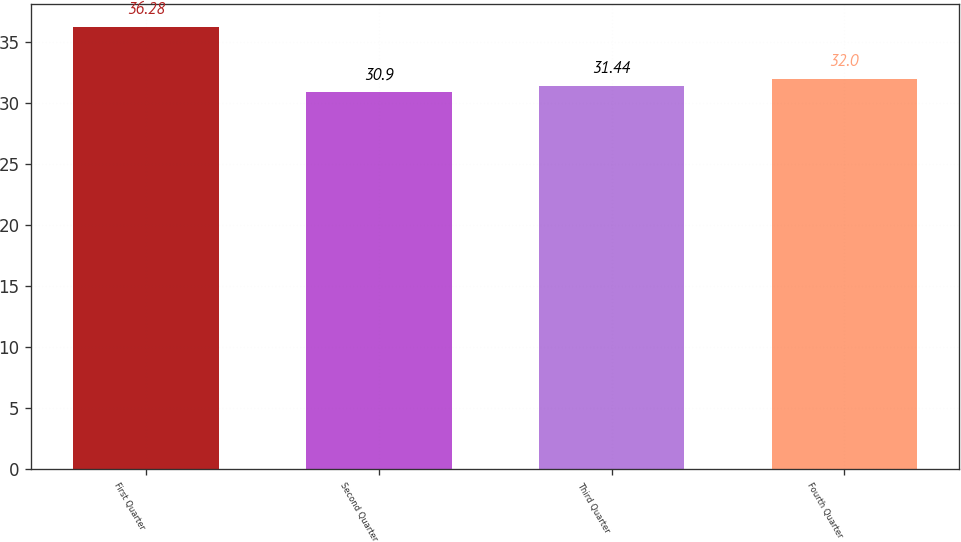<chart> <loc_0><loc_0><loc_500><loc_500><bar_chart><fcel>First Quarter<fcel>Second Quarter<fcel>Third Quarter<fcel>Fourth Quarter<nl><fcel>36.28<fcel>30.9<fcel>31.44<fcel>32<nl></chart> 